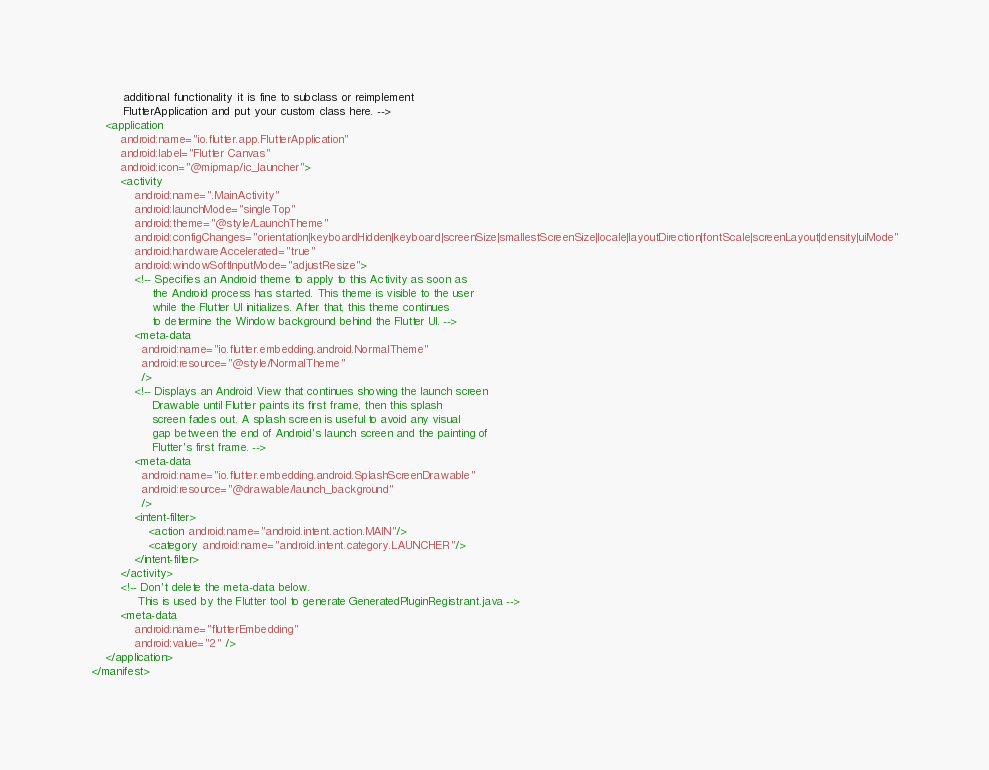Convert code to text. <code><loc_0><loc_0><loc_500><loc_500><_XML_>         additional functionality it is fine to subclass or reimplement
         FlutterApplication and put your custom class here. -->
    <application
        android:name="io.flutter.app.FlutterApplication"
        android:label="Flutter Canvas"
        android:icon="@mipmap/ic_launcher">
        <activity
            android:name=".MainActivity"
            android:launchMode="singleTop"
            android:theme="@style/LaunchTheme"
            android:configChanges="orientation|keyboardHidden|keyboard|screenSize|smallestScreenSize|locale|layoutDirection|fontScale|screenLayout|density|uiMode"
            android:hardwareAccelerated="true"
            android:windowSoftInputMode="adjustResize">
            <!-- Specifies an Android theme to apply to this Activity as soon as
                 the Android process has started. This theme is visible to the user
                 while the Flutter UI initializes. After that, this theme continues
                 to determine the Window background behind the Flutter UI. -->
            <meta-data
              android:name="io.flutter.embedding.android.NormalTheme"
              android:resource="@style/NormalTheme"
              />
            <!-- Displays an Android View that continues showing the launch screen
                 Drawable until Flutter paints its first frame, then this splash
                 screen fades out. A splash screen is useful to avoid any visual
                 gap between the end of Android's launch screen and the painting of
                 Flutter's first frame. -->
            <meta-data
              android:name="io.flutter.embedding.android.SplashScreenDrawable"
              android:resource="@drawable/launch_background"
              />
            <intent-filter>
                <action android:name="android.intent.action.MAIN"/>
                <category android:name="android.intent.category.LAUNCHER"/>
            </intent-filter>
        </activity>
        <!-- Don't delete the meta-data below.
             This is used by the Flutter tool to generate GeneratedPluginRegistrant.java -->
        <meta-data
            android:name="flutterEmbedding"
            android:value="2" />
    </application>
</manifest>
</code> 